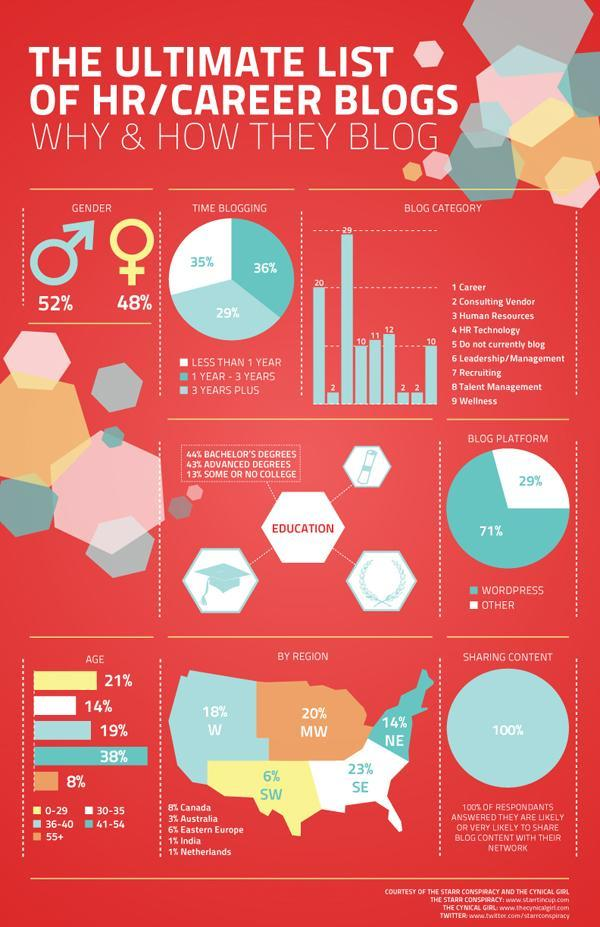What percentage of HR/Career blogs are driven by Males?
Answer the question with a short phrase. 52% Which platform owns the major blog traffic? Wordpress 